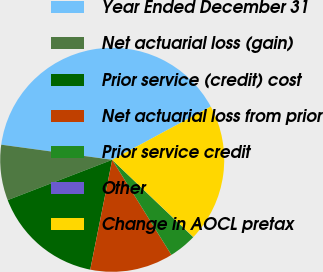<chart> <loc_0><loc_0><loc_500><loc_500><pie_chart><fcel>Year Ended December 31<fcel>Net actuarial loss (gain)<fcel>Prior service (credit) cost<fcel>Net actuarial loss from prior<fcel>Prior service credit<fcel>Other<fcel>Change in AOCL pretax<nl><fcel>39.96%<fcel>8.01%<fcel>16.0%<fcel>12.0%<fcel>4.01%<fcel>0.02%<fcel>19.99%<nl></chart> 